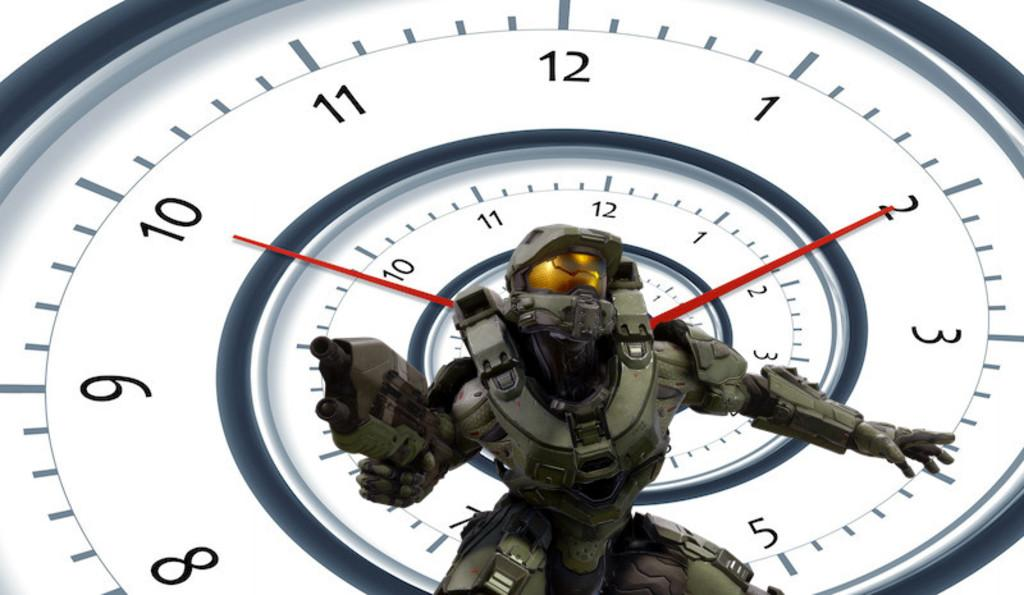<image>
Summarize the visual content of the image. A futuristic army type figure posed on a clock showing the time as 10:10. 